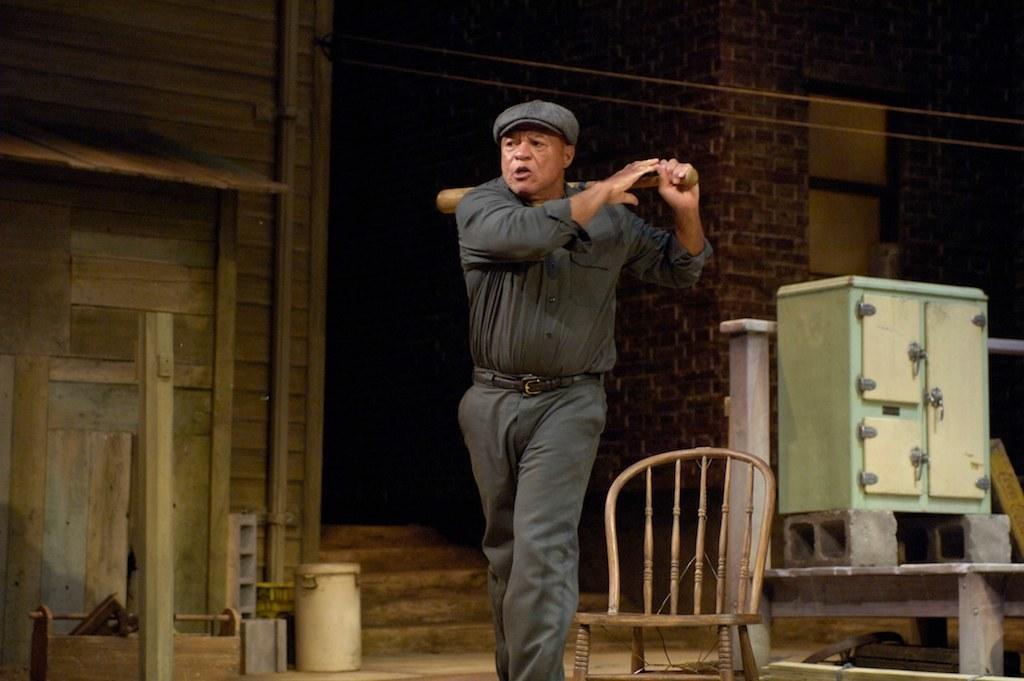Describe this image in one or two sentences. Here is a man standing and holding bat in his hand. In the background we can see wall,chair,window. 